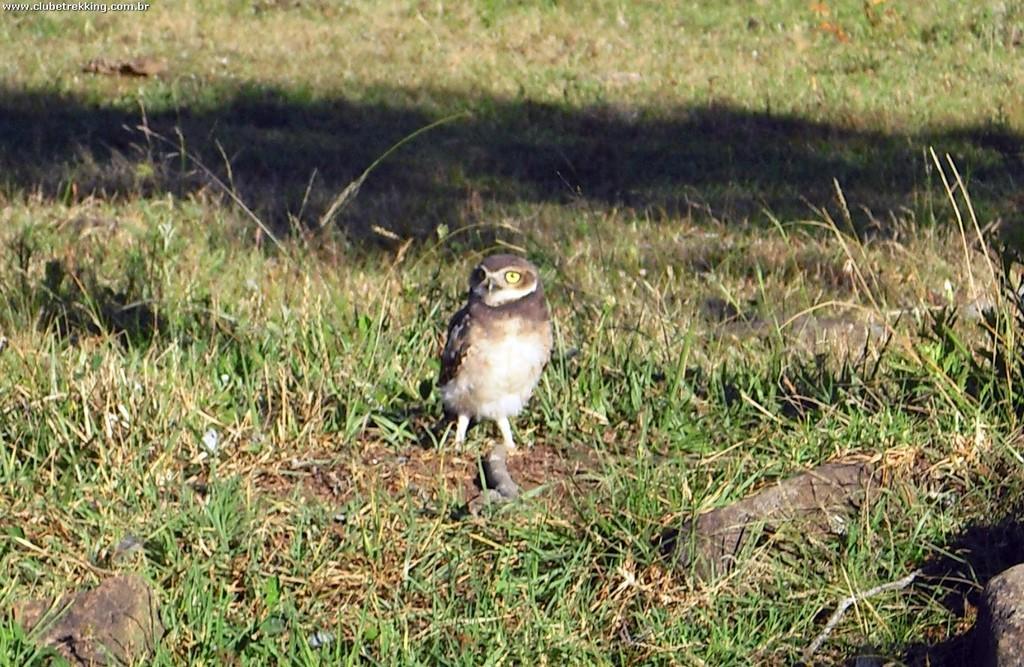Could you give a brief overview of what you see in this image? This image is clicked outside. There is grass in this image. There is a bird in the middle. 